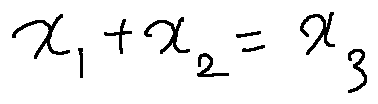<formula> <loc_0><loc_0><loc_500><loc_500>x _ { 1 } + x _ { 2 } = x _ { 3 }</formula> 